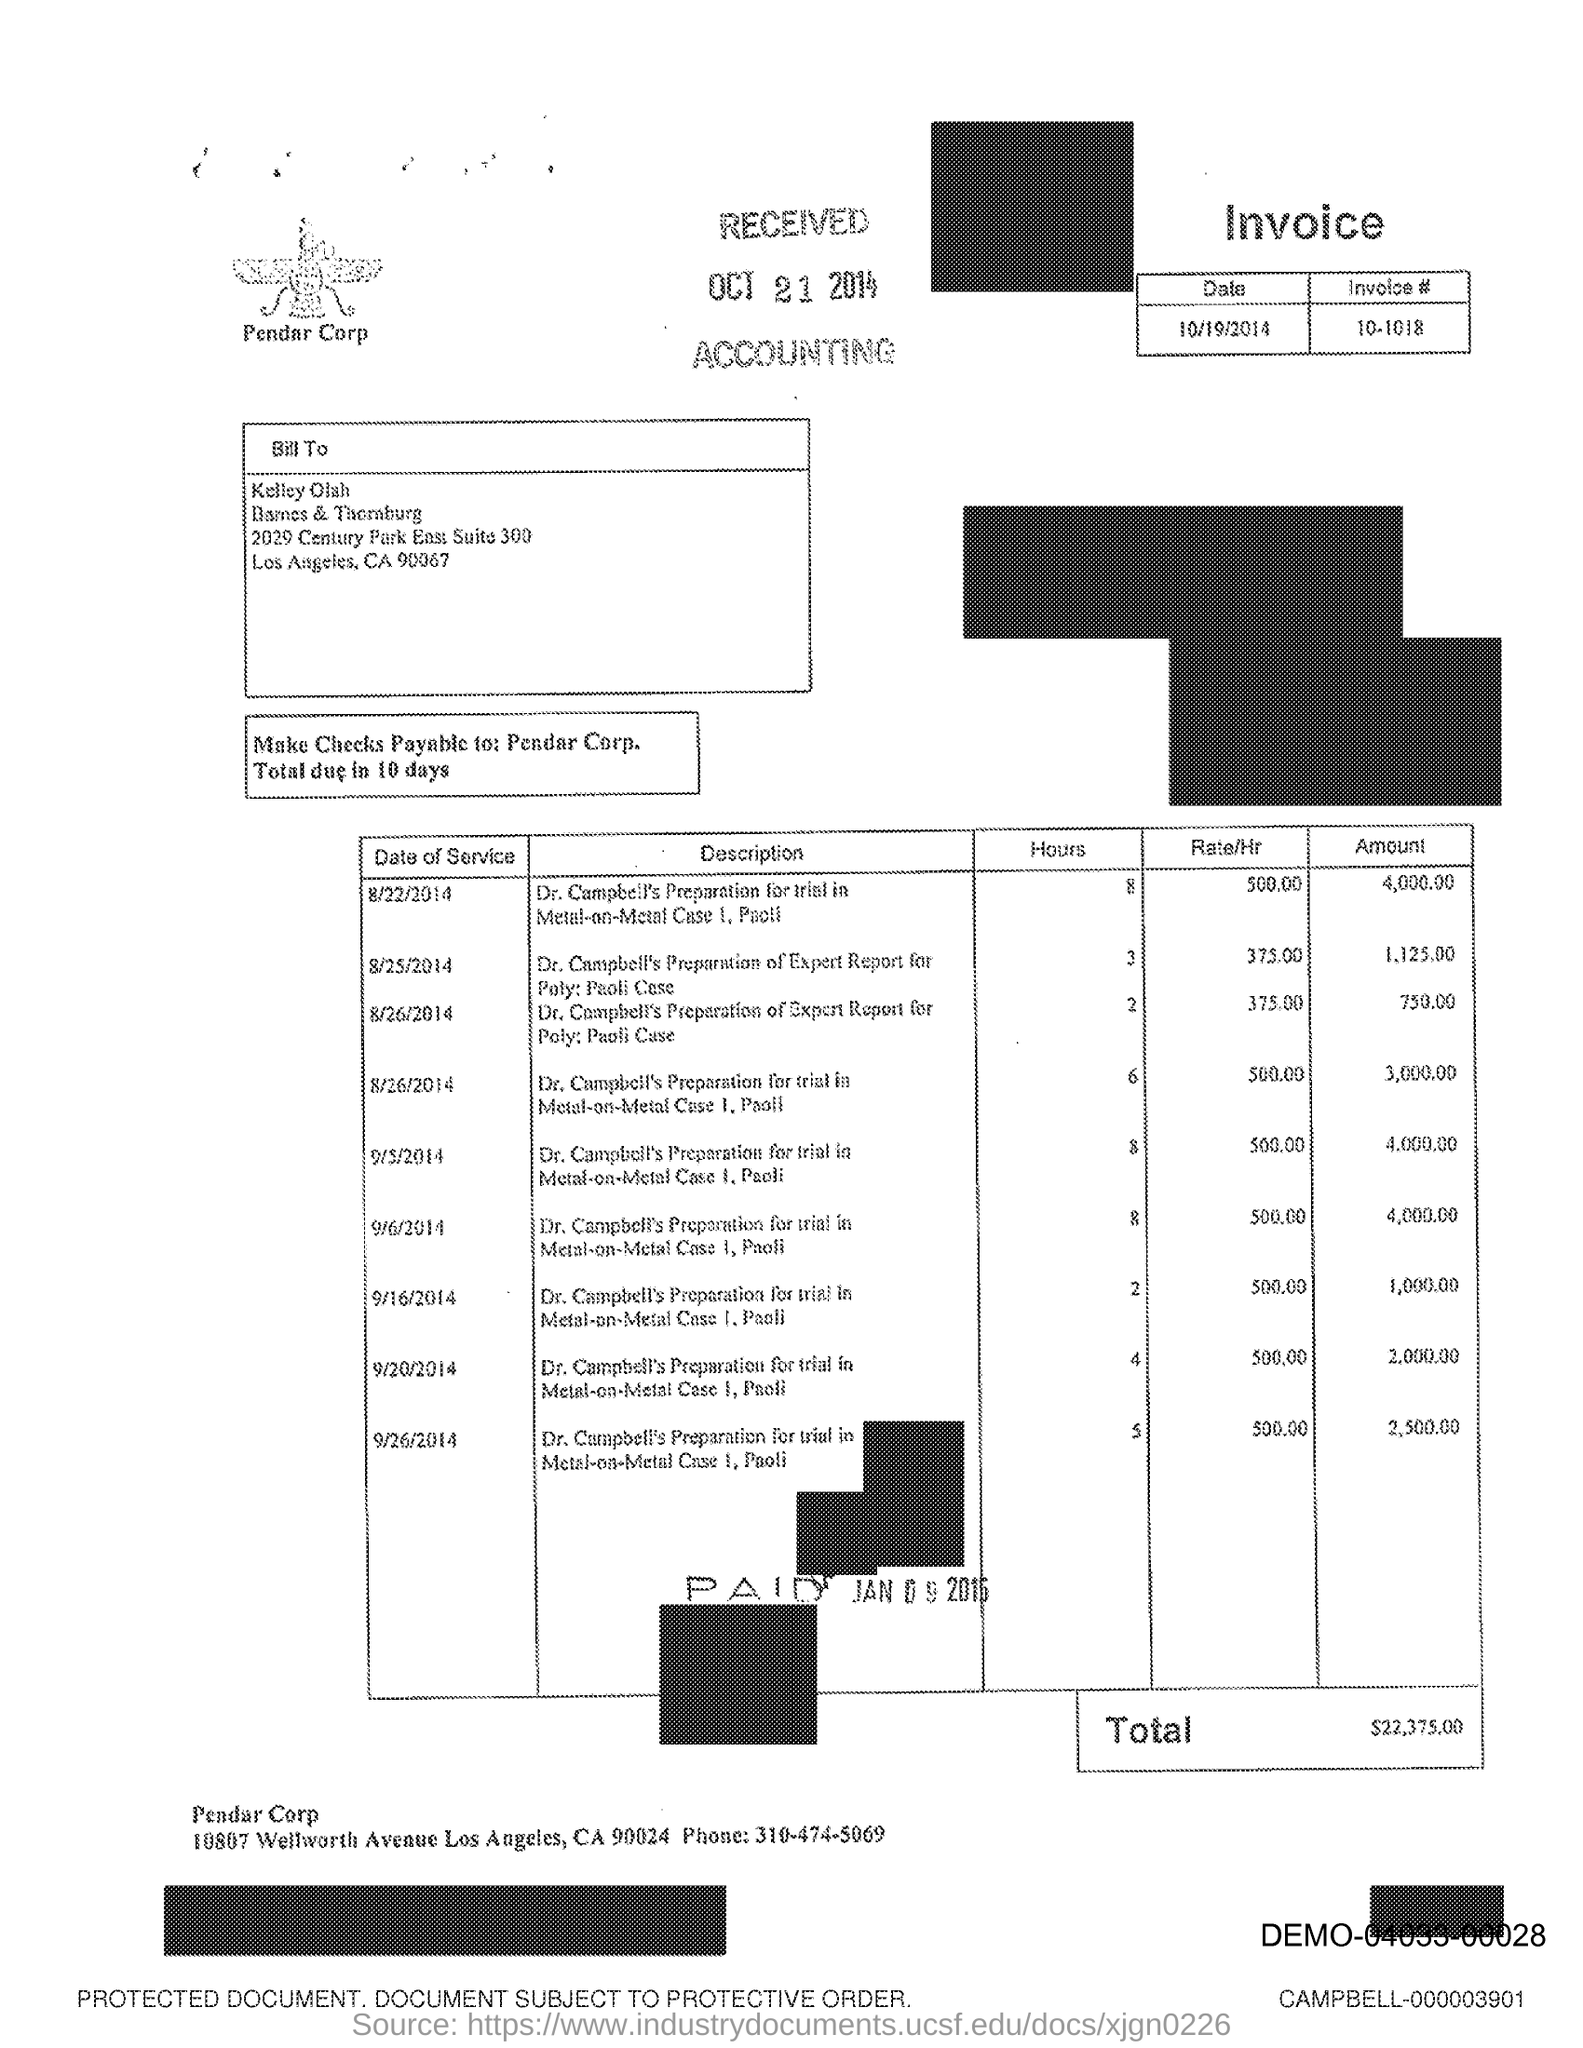Highlight a few significant elements in this photo. The phone number mentioned in the document is 310-474-5069. 